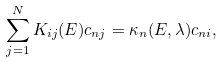<formula> <loc_0><loc_0><loc_500><loc_500>\sum _ { j = 1 } ^ { N } K _ { i j } ( E ) c _ { n j } = \kappa _ { n } ( E , \lambda ) c _ { n i } ,</formula> 